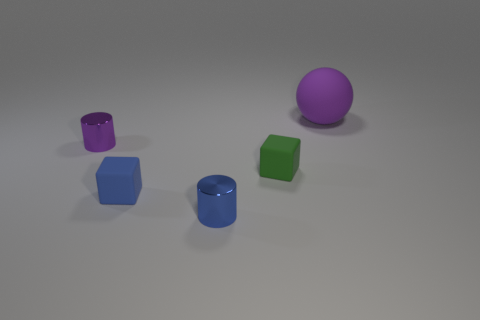Add 1 cylinders. How many objects exist? 6 Subtract all blue metallic balls. Subtract all shiny things. How many objects are left? 3 Add 4 shiny cylinders. How many shiny cylinders are left? 6 Add 2 small red matte spheres. How many small red matte spheres exist? 2 Subtract 0 brown balls. How many objects are left? 5 Subtract all cylinders. How many objects are left? 3 